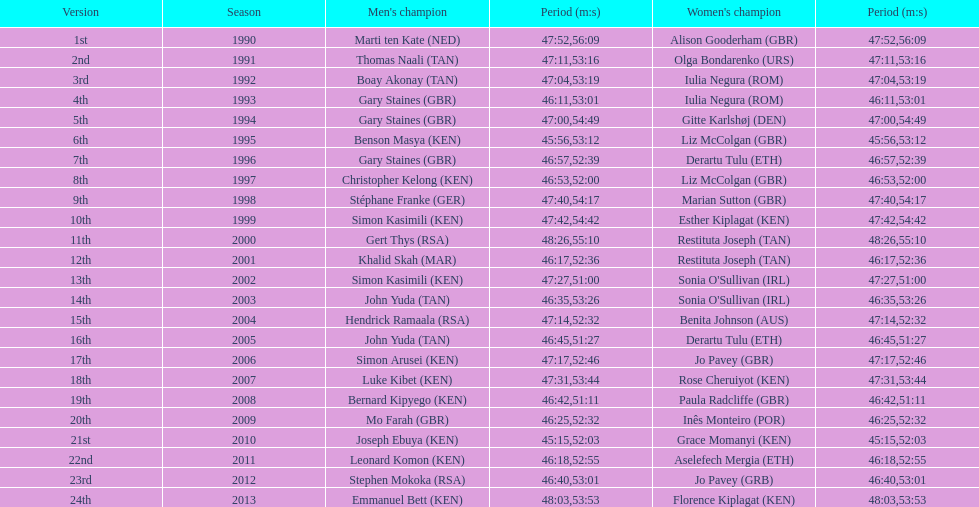In how many instances has a single country triumphed in both the men's and women's divisions of the bupa great south run? 4. 